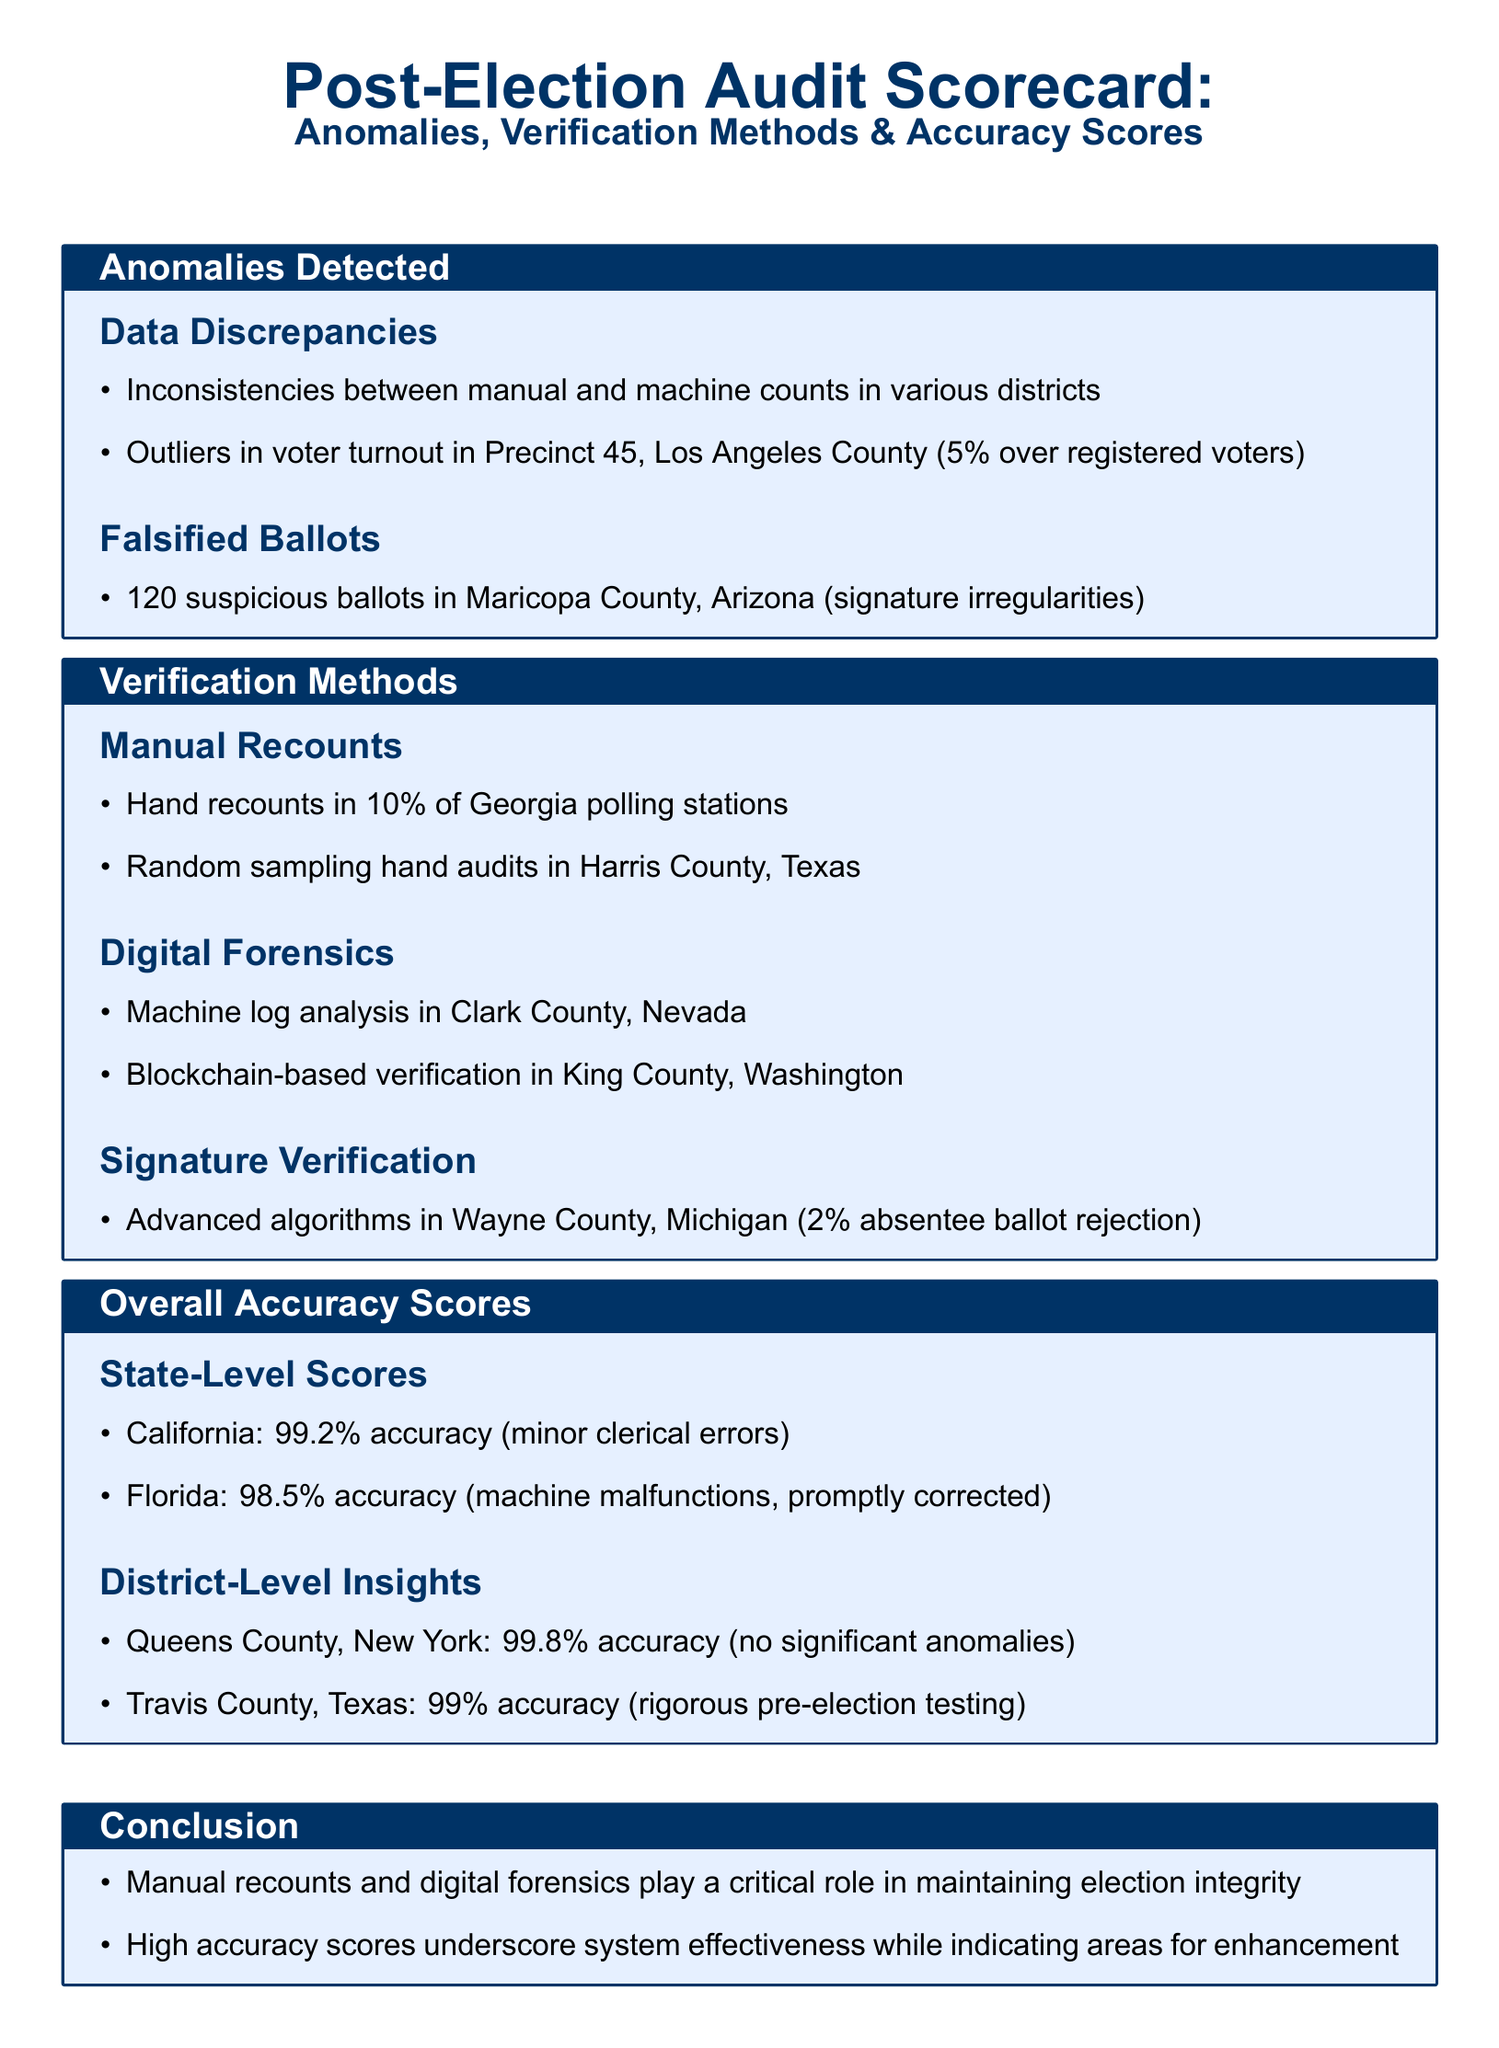What is the accuracy score for California? The accuracy score for California is found in the Overall Accuracy Scores section, listing the number as 99.2%.
Answer: 99.2% How many suspicious ballots were detected in Maricopa County? The number of suspicious ballots in Maricopa County is specifically listed as 120 in the Anomalies Detected section.
Answer: 120 What verification method was used in Clark County, Nevada? The document details that machine log analysis was employed in Clark County under the Verification Methods section.
Answer: Machine log analysis What percentage of absentee ballots were rejected in Wayne County, Michigan? The rejection percentage is specified in the Signature Verification subsection, which states it is 2%.
Answer: 2% Which county has the highest accuracy score listed? The highest accuracy score can be found in the District-Level Insights subsection, with Queens County, New York noted for its score.
Answer: Queens County, New York What type of audit was performed in 10% of Georgia polling stations? The audit type is mentioned in the Verification Methods section as a manual recount.
Answer: Manual recount Which county had an outlier in voter turnout with 5% over registered voters? The document mentions Precinct 45, Los Angeles County, specifically in the Anomalies Detected section.
Answer: Precinct 45, Los Angeles County What is the overall conclusion regarding manual recounts and digital forensics? The conclusion summarizes their critical role in maintaining election integrity, as stated in the Conclusion section.
Answer: Critical role 